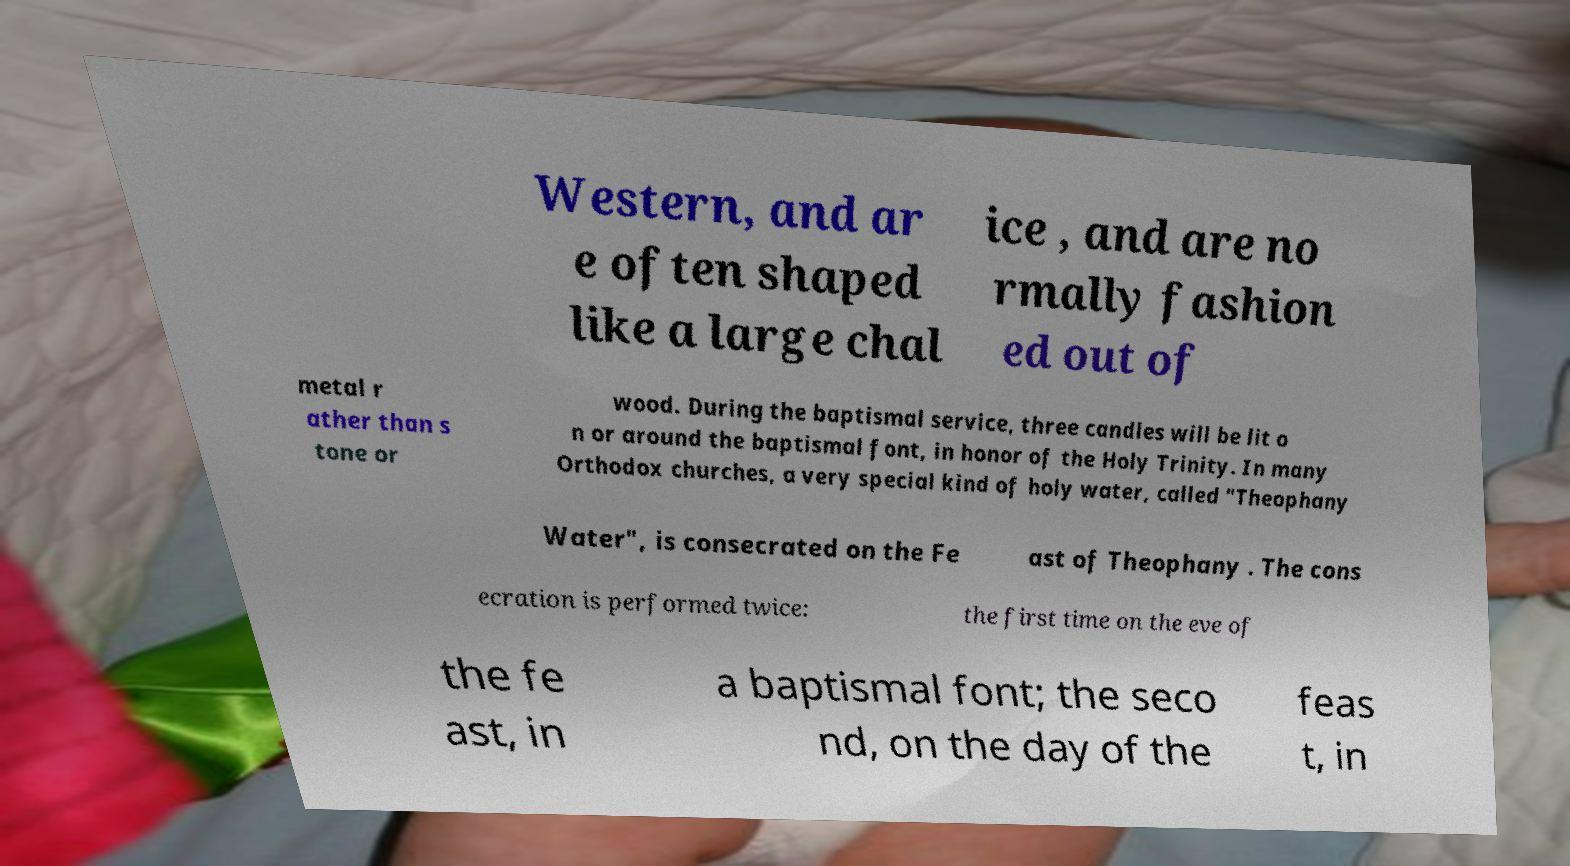There's text embedded in this image that I need extracted. Can you transcribe it verbatim? Western, and ar e often shaped like a large chal ice , and are no rmally fashion ed out of metal r ather than s tone or wood. During the baptismal service, three candles will be lit o n or around the baptismal font, in honor of the Holy Trinity. In many Orthodox churches, a very special kind of holy water, called "Theophany Water", is consecrated on the Fe ast of Theophany . The cons ecration is performed twice: the first time on the eve of the fe ast, in a baptismal font; the seco nd, on the day of the feas t, in 